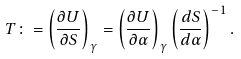Convert formula to latex. <formula><loc_0><loc_0><loc_500><loc_500>T \colon = \left ( \frac { \partial U } { \partial S } \right ) _ { \gamma } = \left ( \frac { \partial U } { \partial \alpha } \right ) _ { \gamma } \left ( \frac { d S } { d \alpha } \right ) ^ { - 1 } .</formula> 